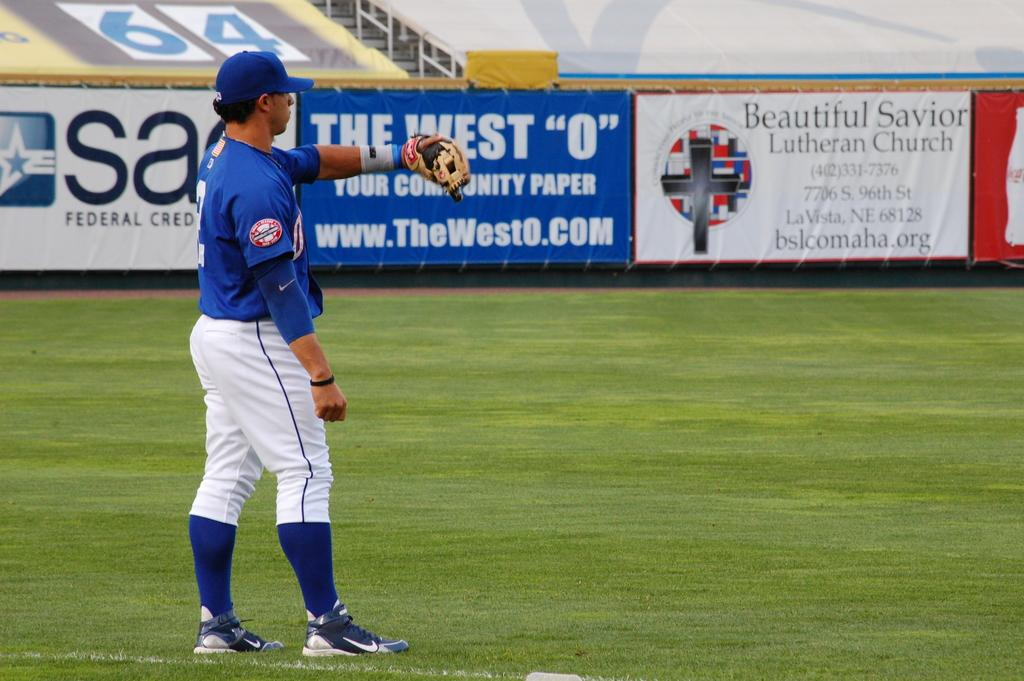<image>
Share a concise interpretation of the image provided. A man in a blue and white baseball uniform as there is a banner that says Beautiful Savior Lutheran Church 